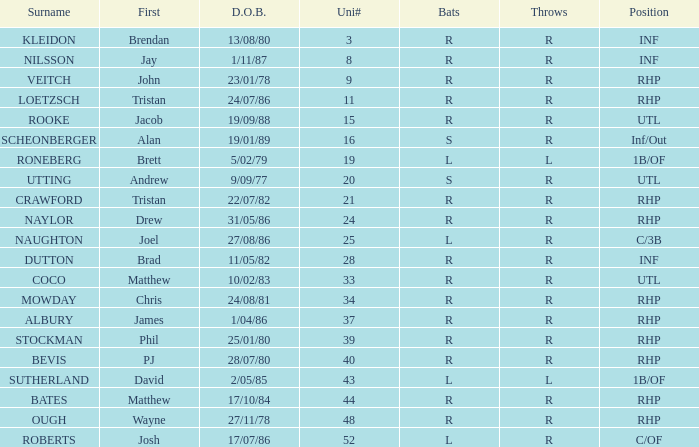How many Uni numbers have Bats of s, and a Position of utl? 1.0. Can you give me this table as a dict? {'header': ['Surname', 'First', 'D.O.B.', 'Uni#', 'Bats', 'Throws', 'Position'], 'rows': [['KLEIDON', 'Brendan', '13/08/80', '3', 'R', 'R', 'INF'], ['NILSSON', 'Jay', '1/11/87', '8', 'R', 'R', 'INF'], ['VEITCH', 'John', '23/01/78', '9', 'R', 'R', 'RHP'], ['LOETZSCH', 'Tristan', '24/07/86', '11', 'R', 'R', 'RHP'], ['ROOKE', 'Jacob', '19/09/88', '15', 'R', 'R', 'UTL'], ['SCHEONBERGER', 'Alan', '19/01/89', '16', 'S', 'R', 'Inf/Out'], ['RONEBERG', 'Brett', '5/02/79', '19', 'L', 'L', '1B/OF'], ['UTTING', 'Andrew', '9/09/77', '20', 'S', 'R', 'UTL'], ['CRAWFORD', 'Tristan', '22/07/82', '21', 'R', 'R', 'RHP'], ['NAYLOR', 'Drew', '31/05/86', '24', 'R', 'R', 'RHP'], ['NAUGHTON', 'Joel', '27/08/86', '25', 'L', 'R', 'C/3B'], ['DUTTON', 'Brad', '11/05/82', '28', 'R', 'R', 'INF'], ['COCO', 'Matthew', '10/02/83', '33', 'R', 'R', 'UTL'], ['MOWDAY', 'Chris', '24/08/81', '34', 'R', 'R', 'RHP'], ['ALBURY', 'James', '1/04/86', '37', 'R', 'R', 'RHP'], ['STOCKMAN', 'Phil', '25/01/80', '39', 'R', 'R', 'RHP'], ['BEVIS', 'PJ', '28/07/80', '40', 'R', 'R', 'RHP'], ['SUTHERLAND', 'David', '2/05/85', '43', 'L', 'L', '1B/OF'], ['BATES', 'Matthew', '17/10/84', '44', 'R', 'R', 'RHP'], ['OUGH', 'Wayne', '27/11/78', '48', 'R', 'R', 'RHP'], ['ROBERTS', 'Josh', '17/07/86', '52', 'L', 'R', 'C/OF']]} 